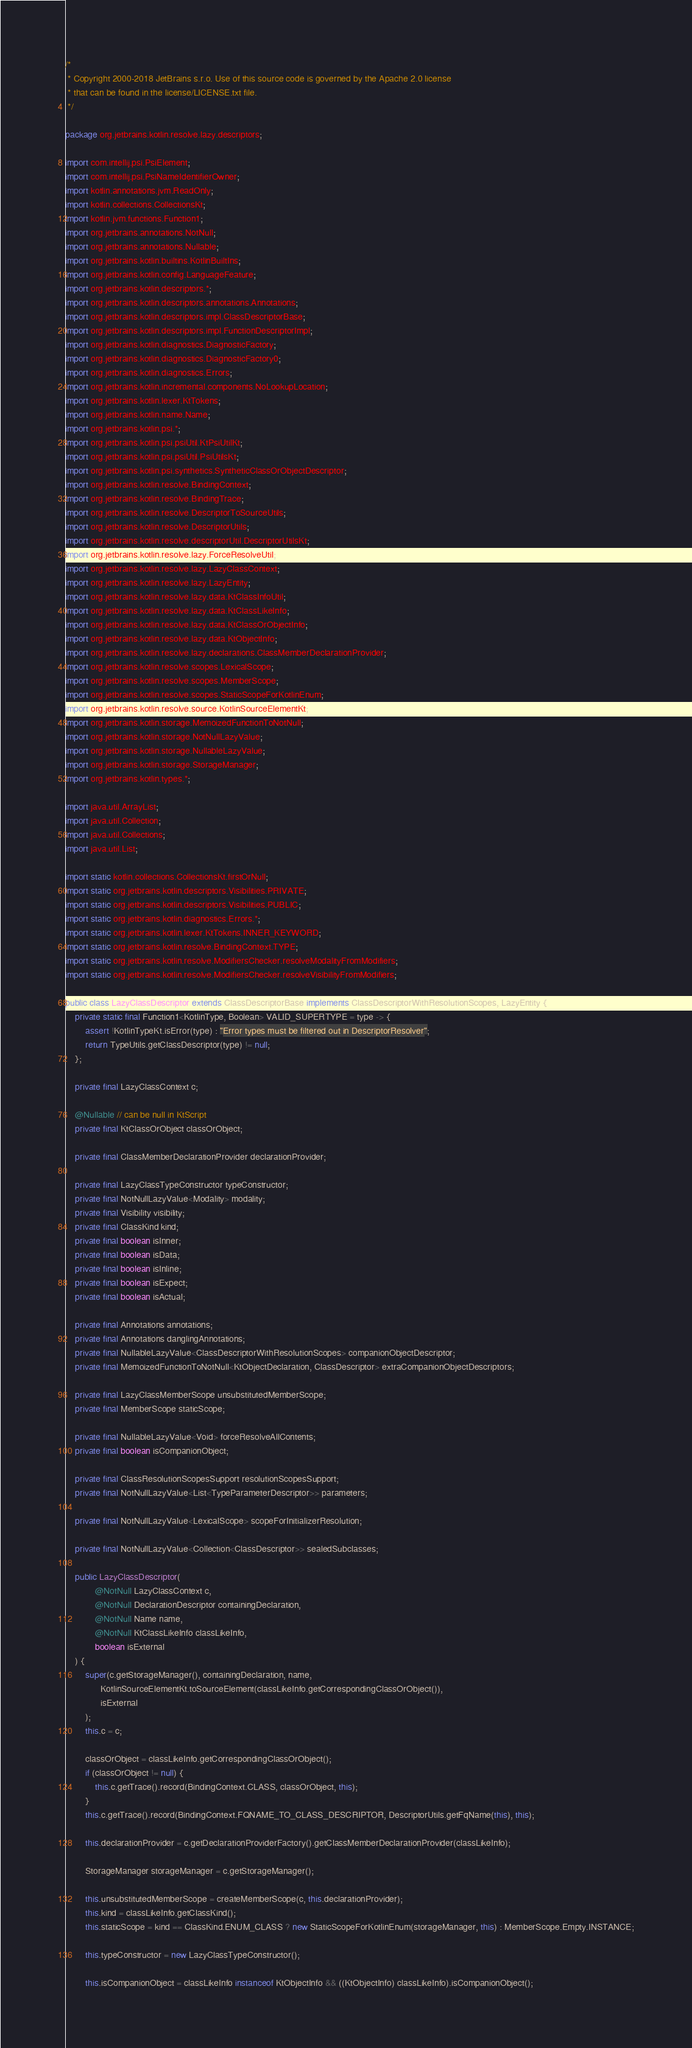Convert code to text. <code><loc_0><loc_0><loc_500><loc_500><_Java_>/*
 * Copyright 2000-2018 JetBrains s.r.o. Use of this source code is governed by the Apache 2.0 license
 * that can be found in the license/LICENSE.txt file.
 */

package org.jetbrains.kotlin.resolve.lazy.descriptors;

import com.intellij.psi.PsiElement;
import com.intellij.psi.PsiNameIdentifierOwner;
import kotlin.annotations.jvm.ReadOnly;
import kotlin.collections.CollectionsKt;
import kotlin.jvm.functions.Function1;
import org.jetbrains.annotations.NotNull;
import org.jetbrains.annotations.Nullable;
import org.jetbrains.kotlin.builtins.KotlinBuiltIns;
import org.jetbrains.kotlin.config.LanguageFeature;
import org.jetbrains.kotlin.descriptors.*;
import org.jetbrains.kotlin.descriptors.annotations.Annotations;
import org.jetbrains.kotlin.descriptors.impl.ClassDescriptorBase;
import org.jetbrains.kotlin.descriptors.impl.FunctionDescriptorImpl;
import org.jetbrains.kotlin.diagnostics.DiagnosticFactory;
import org.jetbrains.kotlin.diagnostics.DiagnosticFactory0;
import org.jetbrains.kotlin.diagnostics.Errors;
import org.jetbrains.kotlin.incremental.components.NoLookupLocation;
import org.jetbrains.kotlin.lexer.KtTokens;
import org.jetbrains.kotlin.name.Name;
import org.jetbrains.kotlin.psi.*;
import org.jetbrains.kotlin.psi.psiUtil.KtPsiUtilKt;
import org.jetbrains.kotlin.psi.psiUtil.PsiUtilsKt;
import org.jetbrains.kotlin.psi.synthetics.SyntheticClassOrObjectDescriptor;
import org.jetbrains.kotlin.resolve.BindingContext;
import org.jetbrains.kotlin.resolve.BindingTrace;
import org.jetbrains.kotlin.resolve.DescriptorToSourceUtils;
import org.jetbrains.kotlin.resolve.DescriptorUtils;
import org.jetbrains.kotlin.resolve.descriptorUtil.DescriptorUtilsKt;
import org.jetbrains.kotlin.resolve.lazy.ForceResolveUtil;
import org.jetbrains.kotlin.resolve.lazy.LazyClassContext;
import org.jetbrains.kotlin.resolve.lazy.LazyEntity;
import org.jetbrains.kotlin.resolve.lazy.data.KtClassInfoUtil;
import org.jetbrains.kotlin.resolve.lazy.data.KtClassLikeInfo;
import org.jetbrains.kotlin.resolve.lazy.data.KtClassOrObjectInfo;
import org.jetbrains.kotlin.resolve.lazy.data.KtObjectInfo;
import org.jetbrains.kotlin.resolve.lazy.declarations.ClassMemberDeclarationProvider;
import org.jetbrains.kotlin.resolve.scopes.LexicalScope;
import org.jetbrains.kotlin.resolve.scopes.MemberScope;
import org.jetbrains.kotlin.resolve.scopes.StaticScopeForKotlinEnum;
import org.jetbrains.kotlin.resolve.source.KotlinSourceElementKt;
import org.jetbrains.kotlin.storage.MemoizedFunctionToNotNull;
import org.jetbrains.kotlin.storage.NotNullLazyValue;
import org.jetbrains.kotlin.storage.NullableLazyValue;
import org.jetbrains.kotlin.storage.StorageManager;
import org.jetbrains.kotlin.types.*;

import java.util.ArrayList;
import java.util.Collection;
import java.util.Collections;
import java.util.List;

import static kotlin.collections.CollectionsKt.firstOrNull;
import static org.jetbrains.kotlin.descriptors.Visibilities.PRIVATE;
import static org.jetbrains.kotlin.descriptors.Visibilities.PUBLIC;
import static org.jetbrains.kotlin.diagnostics.Errors.*;
import static org.jetbrains.kotlin.lexer.KtTokens.INNER_KEYWORD;
import static org.jetbrains.kotlin.resolve.BindingContext.TYPE;
import static org.jetbrains.kotlin.resolve.ModifiersChecker.resolveModalityFromModifiers;
import static org.jetbrains.kotlin.resolve.ModifiersChecker.resolveVisibilityFromModifiers;

public class LazyClassDescriptor extends ClassDescriptorBase implements ClassDescriptorWithResolutionScopes, LazyEntity {
    private static final Function1<KotlinType, Boolean> VALID_SUPERTYPE = type -> {
        assert !KotlinTypeKt.isError(type) : "Error types must be filtered out in DescriptorResolver";
        return TypeUtils.getClassDescriptor(type) != null;
    };

    private final LazyClassContext c;

    @Nullable // can be null in KtScript
    private final KtClassOrObject classOrObject;

    private final ClassMemberDeclarationProvider declarationProvider;

    private final LazyClassTypeConstructor typeConstructor;
    private final NotNullLazyValue<Modality> modality;
    private final Visibility visibility;
    private final ClassKind kind;
    private final boolean isInner;
    private final boolean isData;
    private final boolean isInline;
    private final boolean isExpect;
    private final boolean isActual;

    private final Annotations annotations;
    private final Annotations danglingAnnotations;
    private final NullableLazyValue<ClassDescriptorWithResolutionScopes> companionObjectDescriptor;
    private final MemoizedFunctionToNotNull<KtObjectDeclaration, ClassDescriptor> extraCompanionObjectDescriptors;

    private final LazyClassMemberScope unsubstitutedMemberScope;
    private final MemberScope staticScope;

    private final NullableLazyValue<Void> forceResolveAllContents;
    private final boolean isCompanionObject;

    private final ClassResolutionScopesSupport resolutionScopesSupport;
    private final NotNullLazyValue<List<TypeParameterDescriptor>> parameters;

    private final NotNullLazyValue<LexicalScope> scopeForInitializerResolution;

    private final NotNullLazyValue<Collection<ClassDescriptor>> sealedSubclasses;

    public LazyClassDescriptor(
            @NotNull LazyClassContext c,
            @NotNull DeclarationDescriptor containingDeclaration,
            @NotNull Name name,
            @NotNull KtClassLikeInfo classLikeInfo,
            boolean isExternal
    ) {
        super(c.getStorageManager(), containingDeclaration, name,
              KotlinSourceElementKt.toSourceElement(classLikeInfo.getCorrespondingClassOrObject()),
              isExternal
        );
        this.c = c;

        classOrObject = classLikeInfo.getCorrespondingClassOrObject();
        if (classOrObject != null) {
            this.c.getTrace().record(BindingContext.CLASS, classOrObject, this);
        }
        this.c.getTrace().record(BindingContext.FQNAME_TO_CLASS_DESCRIPTOR, DescriptorUtils.getFqName(this), this);

        this.declarationProvider = c.getDeclarationProviderFactory().getClassMemberDeclarationProvider(classLikeInfo);

        StorageManager storageManager = c.getStorageManager();

        this.unsubstitutedMemberScope = createMemberScope(c, this.declarationProvider);
        this.kind = classLikeInfo.getClassKind();
        this.staticScope = kind == ClassKind.ENUM_CLASS ? new StaticScopeForKotlinEnum(storageManager, this) : MemberScope.Empty.INSTANCE;

        this.typeConstructor = new LazyClassTypeConstructor();

        this.isCompanionObject = classLikeInfo instanceof KtObjectInfo && ((KtObjectInfo) classLikeInfo).isCompanionObject();
</code> 